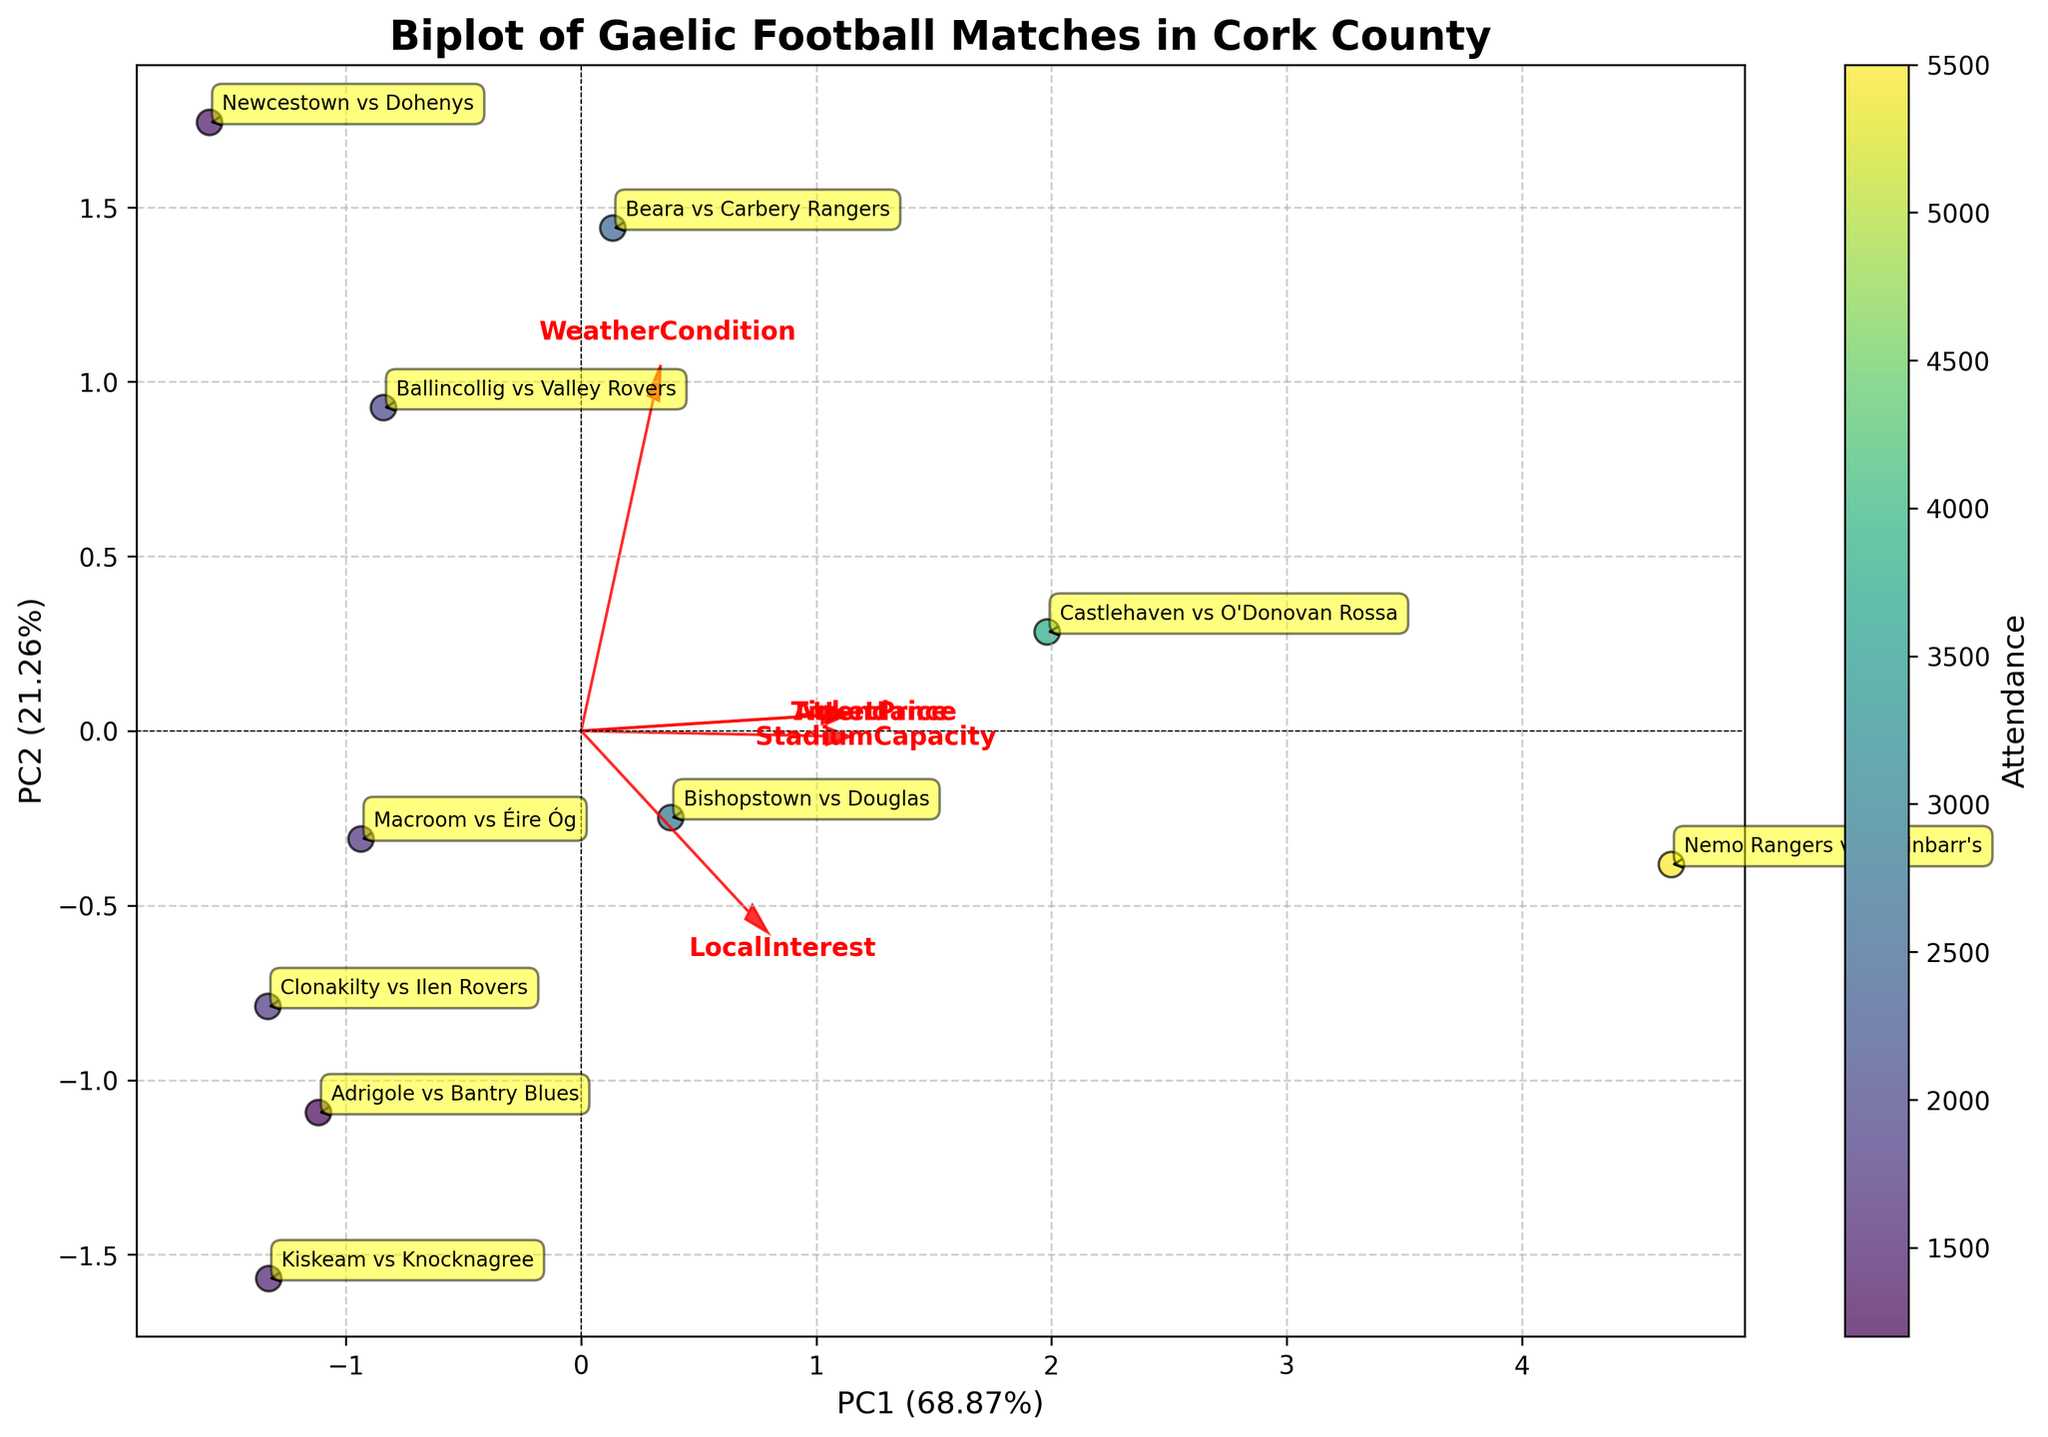What's the title of the plot? The title of the plot is displayed at the top and usually serves as a summary of the plot's purpose or subject. In this case, the title is "Biplot of Gaelic Football Matches in Cork County."
Answer: Biplot of Gaelic Football Matches in Cork County How many matches are represented in the biplot? To determine the number of matches, we count the number of annotated points or labels in the plot. There are 10 matches mentioned.
Answer: 10 Which match has the highest attendance? The color gradient on the plot represents the attendance, with the match having the darkest color indicating the highest attendance. "Nemo Rangers vs St Finbarr's" shows the darkest color.
Answer: Nemo Rangers vs St Finbarr's What percentage of the variance is explained by PC1? The percentage of variance explained by each principal component is indicated on the axis labels. PC1 explains 50% of the variance (0.50 is the percentage shown on the X-axis).
Answer: 50% Which feature has the largest loading on PC1? The loading of features on PC1 is illustrated by the length and direction of the red arrows. "StadiumCapacity" has the largest loading on PC1 as its arrow extends the furthest along the PC1 axis.
Answer: StadiumCapacity Is "Attendance" more strongly related to PC1 or PC2? By observing the direction and length of the "Attendance" vector in relation to PC1 and PC2, we note that it aligns more strongly with PC1, as its projection is larger on PC1 than on PC2.
Answer: PC1 Which match has the smallest ticket price and where is it located on the plot? To find the match with the smallest ticket price, look for the point with the least intense color (based on the color bar for attendance) and the smallest ticket price annotation. "Adrigole vs Bantry Blues" has the smallest ticket price of 15 and is located on the lower left part of the plot according to the PCA coordinates.
Answer: Adrigole vs Bantry Blues What does the color bar represent? The color bar typically provides a reference for interpreting colors on the plot. In this case, it represents "Attendance" levels with varying intensities corresponding to different attendance numbers.
Answer: Attendance How does "LocalInterest" affect the biplot coordinates? By looking at the direction and length of the "LocalInterest" vector, we see that it is positively correlated with PC1 and slightly with PC2. Vectors pointing towards the positive direction of these components indicate a positive relationship with those principal components.
Answer: Positively correlated with PC1 and slightly with PC2 